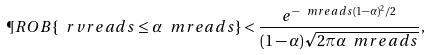<formula> <loc_0><loc_0><loc_500><loc_500>\P R O B \{ \ r v r e a d s \leq \alpha \ m r e a d s \} < \frac { e ^ { - \ m r e a d s ( 1 - \alpha ) ^ { 2 } / 2 } } { ( 1 - \alpha ) \sqrt { 2 \pi \alpha \ m r e a d s } } ,</formula> 